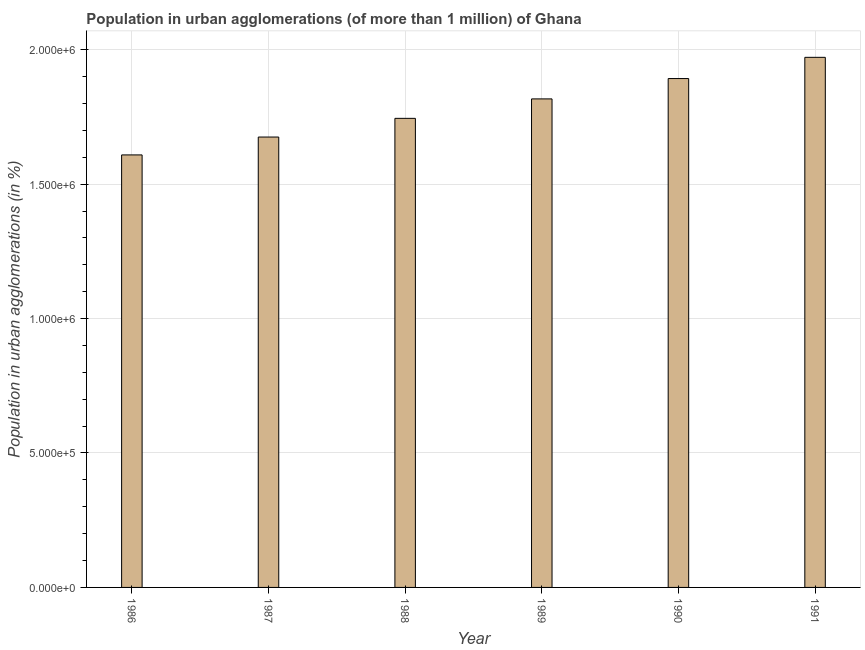Does the graph contain any zero values?
Provide a succinct answer. No. Does the graph contain grids?
Your answer should be very brief. Yes. What is the title of the graph?
Your answer should be very brief. Population in urban agglomerations (of more than 1 million) of Ghana. What is the label or title of the Y-axis?
Make the answer very short. Population in urban agglomerations (in %). What is the population in urban agglomerations in 1991?
Keep it short and to the point. 1.97e+06. Across all years, what is the maximum population in urban agglomerations?
Offer a very short reply. 1.97e+06. Across all years, what is the minimum population in urban agglomerations?
Offer a very short reply. 1.61e+06. In which year was the population in urban agglomerations minimum?
Provide a short and direct response. 1986. What is the sum of the population in urban agglomerations?
Your response must be concise. 1.07e+07. What is the difference between the population in urban agglomerations in 1986 and 1990?
Your answer should be very brief. -2.84e+05. What is the average population in urban agglomerations per year?
Offer a very short reply. 1.79e+06. What is the median population in urban agglomerations?
Provide a succinct answer. 1.78e+06. Is the population in urban agglomerations in 1988 less than that in 1989?
Make the answer very short. Yes. What is the difference between the highest and the second highest population in urban agglomerations?
Keep it short and to the point. 7.90e+04. What is the difference between the highest and the lowest population in urban agglomerations?
Keep it short and to the point. 3.63e+05. How many bars are there?
Provide a succinct answer. 6. Are all the bars in the graph horizontal?
Your answer should be compact. No. What is the difference between two consecutive major ticks on the Y-axis?
Make the answer very short. 5.00e+05. Are the values on the major ticks of Y-axis written in scientific E-notation?
Offer a very short reply. Yes. What is the Population in urban agglomerations (in %) of 1986?
Provide a short and direct response. 1.61e+06. What is the Population in urban agglomerations (in %) in 1987?
Offer a very short reply. 1.68e+06. What is the Population in urban agglomerations (in %) in 1988?
Make the answer very short. 1.74e+06. What is the Population in urban agglomerations (in %) of 1989?
Offer a very short reply. 1.82e+06. What is the Population in urban agglomerations (in %) of 1990?
Offer a very short reply. 1.89e+06. What is the Population in urban agglomerations (in %) in 1991?
Provide a succinct answer. 1.97e+06. What is the difference between the Population in urban agglomerations (in %) in 1986 and 1987?
Keep it short and to the point. -6.65e+04. What is the difference between the Population in urban agglomerations (in %) in 1986 and 1988?
Your answer should be compact. -1.36e+05. What is the difference between the Population in urban agglomerations (in %) in 1986 and 1989?
Your response must be concise. -2.08e+05. What is the difference between the Population in urban agglomerations (in %) in 1986 and 1990?
Give a very brief answer. -2.84e+05. What is the difference between the Population in urban agglomerations (in %) in 1986 and 1991?
Offer a terse response. -3.63e+05. What is the difference between the Population in urban agglomerations (in %) in 1987 and 1988?
Make the answer very short. -6.95e+04. What is the difference between the Population in urban agglomerations (in %) in 1987 and 1989?
Give a very brief answer. -1.42e+05. What is the difference between the Population in urban agglomerations (in %) in 1987 and 1990?
Keep it short and to the point. -2.18e+05. What is the difference between the Population in urban agglomerations (in %) in 1987 and 1991?
Provide a short and direct response. -2.96e+05. What is the difference between the Population in urban agglomerations (in %) in 1988 and 1989?
Your answer should be compact. -7.24e+04. What is the difference between the Population in urban agglomerations (in %) in 1988 and 1990?
Your answer should be compact. -1.48e+05. What is the difference between the Population in urban agglomerations (in %) in 1988 and 1991?
Keep it short and to the point. -2.27e+05. What is the difference between the Population in urban agglomerations (in %) in 1989 and 1990?
Offer a terse response. -7.56e+04. What is the difference between the Population in urban agglomerations (in %) in 1989 and 1991?
Your answer should be compact. -1.55e+05. What is the difference between the Population in urban agglomerations (in %) in 1990 and 1991?
Keep it short and to the point. -7.90e+04. What is the ratio of the Population in urban agglomerations (in %) in 1986 to that in 1987?
Your answer should be very brief. 0.96. What is the ratio of the Population in urban agglomerations (in %) in 1986 to that in 1988?
Make the answer very short. 0.92. What is the ratio of the Population in urban agglomerations (in %) in 1986 to that in 1989?
Provide a short and direct response. 0.89. What is the ratio of the Population in urban agglomerations (in %) in 1986 to that in 1990?
Your answer should be very brief. 0.85. What is the ratio of the Population in urban agglomerations (in %) in 1986 to that in 1991?
Make the answer very short. 0.82. What is the ratio of the Population in urban agglomerations (in %) in 1987 to that in 1988?
Provide a succinct answer. 0.96. What is the ratio of the Population in urban agglomerations (in %) in 1987 to that in 1989?
Your response must be concise. 0.92. What is the ratio of the Population in urban agglomerations (in %) in 1987 to that in 1990?
Offer a terse response. 0.89. What is the ratio of the Population in urban agglomerations (in %) in 1988 to that in 1990?
Ensure brevity in your answer.  0.92. What is the ratio of the Population in urban agglomerations (in %) in 1988 to that in 1991?
Keep it short and to the point. 0.89. What is the ratio of the Population in urban agglomerations (in %) in 1989 to that in 1991?
Keep it short and to the point. 0.92. What is the ratio of the Population in urban agglomerations (in %) in 1990 to that in 1991?
Provide a succinct answer. 0.96. 